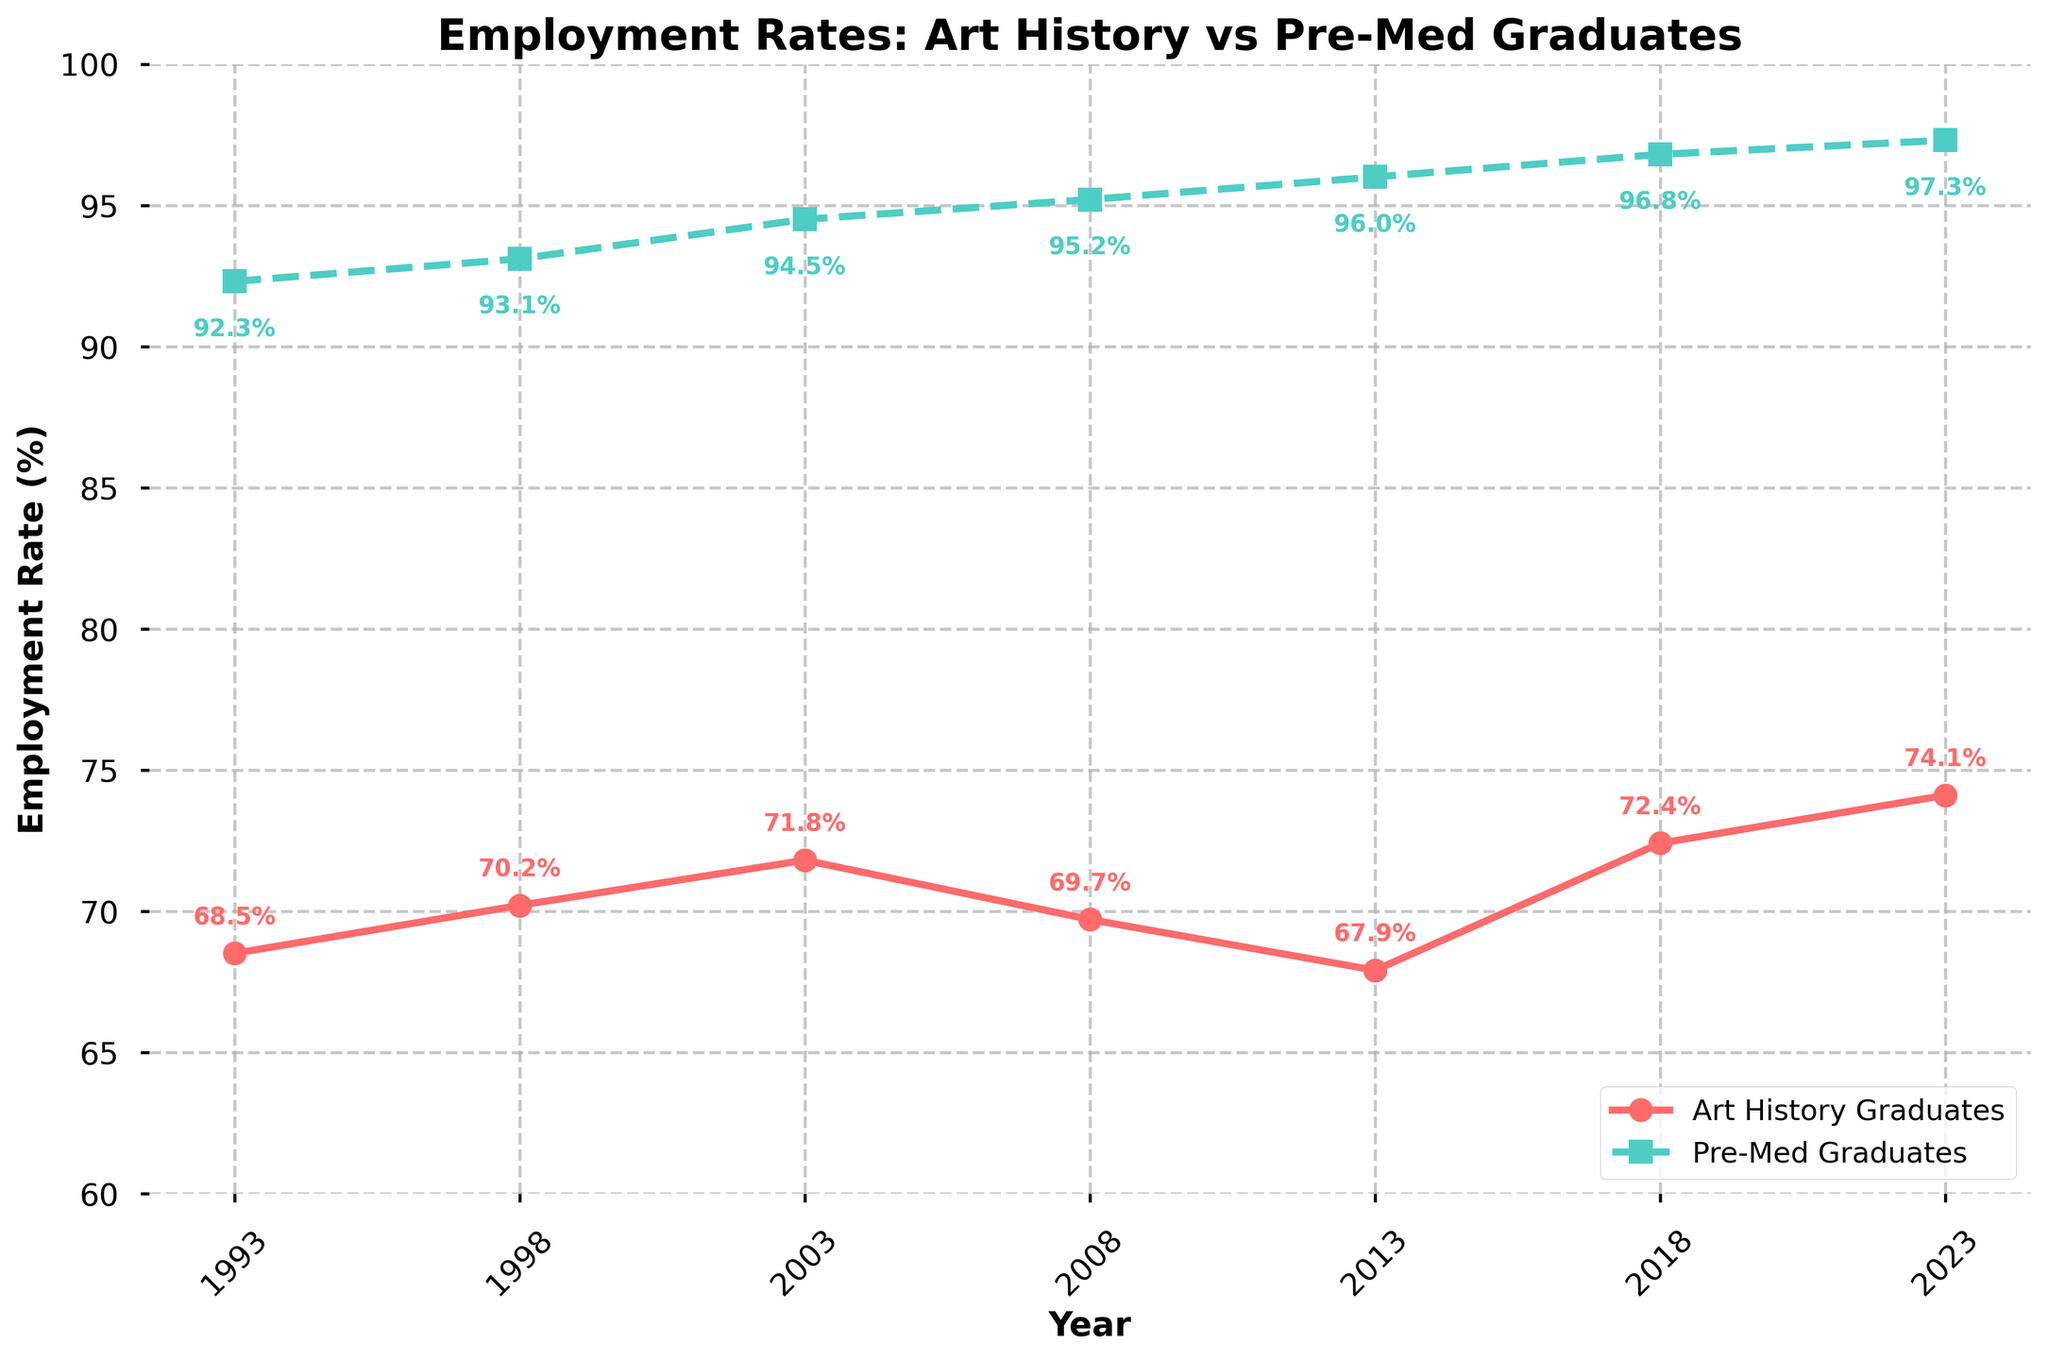What is the employment rate of art history graduates in 2008? The employment rate of art history graduates can be found by locating the point corresponding to the year 2008 on the red line. It is annotated next to the point.
Answer: 69.7% What is the trend in employment rates for pre-med graduates over the last 30 years? The green line for pre-med graduates consistently increases over the years from 1993 to 2023, showing a rising trend.
Answer: Increasing What was the difference in employment rates between the two groups in 2013? In 2013, the employment rate for art history graduates is 67.9%, and for pre-med graduates, it is 96.0%. The difference can be calculated by subtracting the two rates: 96.0% - 67.9% = 28.1%.
Answer: 28.1% Which group had a higher employment rate in 1998? By comparing the annotations for 1998, the red line indicates 70.2% for art history graduates and the green line indicates 93.1% for pre-med graduates. The pre-med group had a higher rate.
Answer: Pre-med graduates How does the employment rate of art history graduates in 2023 compare to that in 1993? The employment rate in 2023 for art history graduates is 74.1%, and in 1993, it was 68.5%. Comparing the two values, 74.1% is higher than 68.5%.
Answer: Higher What is the average employment rate for art history graduates over the 30-year period? The employment rates for art history graduates are: 68.5%, 70.2%, 71.8%, 69.7%, 67.9%, 72.4%, and 74.1%. The average can be calculated by summing these values and then dividing by 7. Sum = 494.6, Average = 494.6 / 7 = 70.66%.
Answer: 70.66% Which year had the smallest difference in employment rates between the two groups? Calculating the differences for each year: 
1993: 92.3% - 68.5% = 23.8%, 
1998: 93.1% - 70.2% = 22.9%, 
2003: 94.5% - 71.8% = 22.7%, 
2008: 95.2% - 69.7% = 25.5%, 
2013: 96.0% - 67.9% = 28.1%, 
2018: 96.8% - 72.4% = 24.4%, 
2023: 97.3% - 74.1% = 23.2%. 
The smallest difference is in 2003, 22.7%.
Answer: 2003 Between which two years did the employment rate of art history graduates see the largest increase? By observing the red line, the largest increase occurs between 2013 and 2018 where the rate goes from 67.9% to 72.4%, an increase of 4.5%.
Answer: 2013 and 2018 